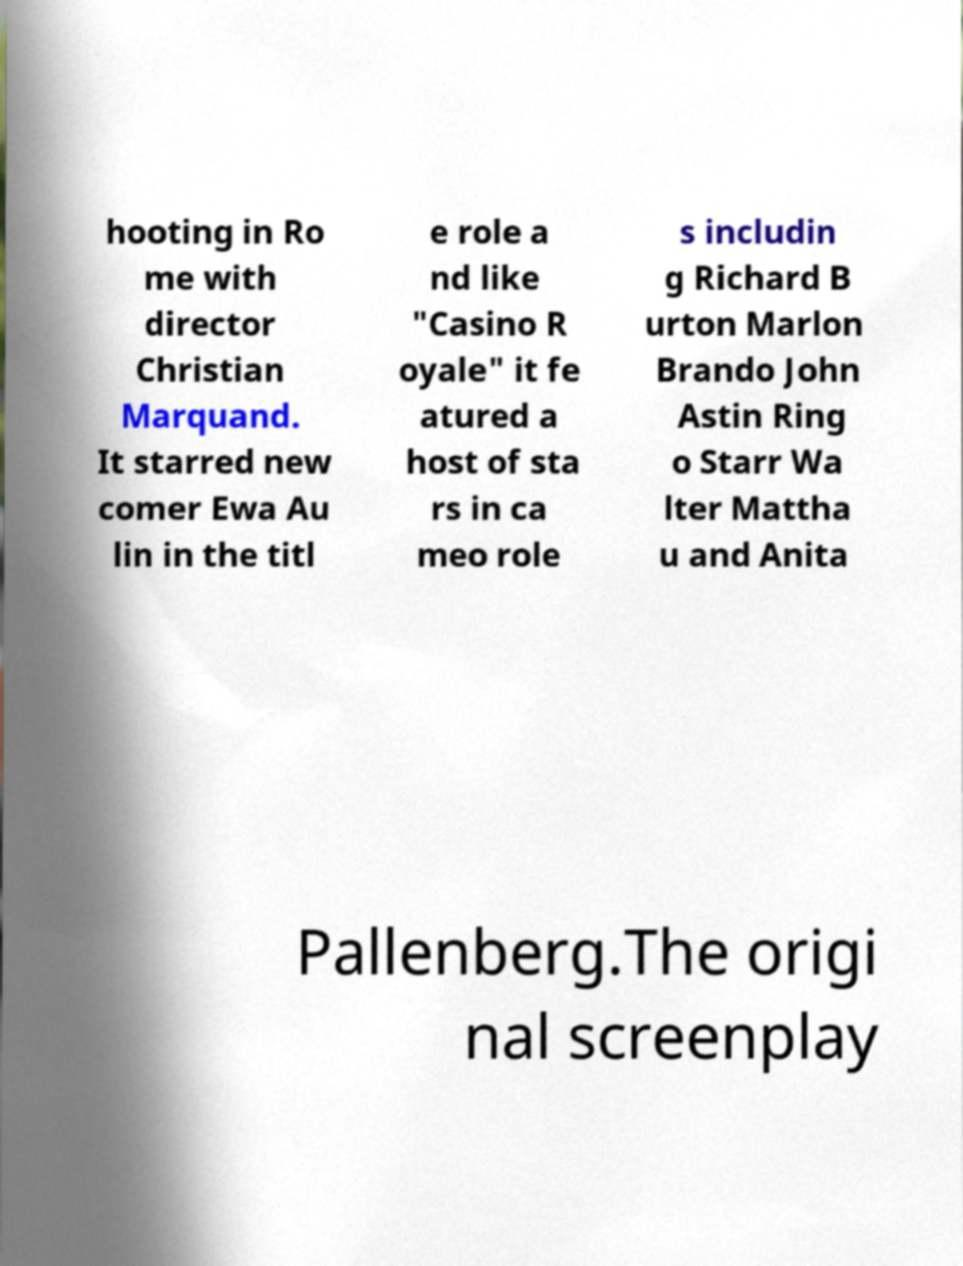For documentation purposes, I need the text within this image transcribed. Could you provide that? hooting in Ro me with director Christian Marquand. It starred new comer Ewa Au lin in the titl e role a nd like "Casino R oyale" it fe atured a host of sta rs in ca meo role s includin g Richard B urton Marlon Brando John Astin Ring o Starr Wa lter Mattha u and Anita Pallenberg.The origi nal screenplay 